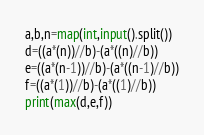Convert code to text. <code><loc_0><loc_0><loc_500><loc_500><_Python_>a,b,n=map(int,input().split())
d=((a*(n))//b)-(a*((n)//b))
e=((a*(n-1))//b)-(a*((n-1)//b))
f=((a*(1))//b)-(a*((1)//b))
print(max(d,e,f))</code> 